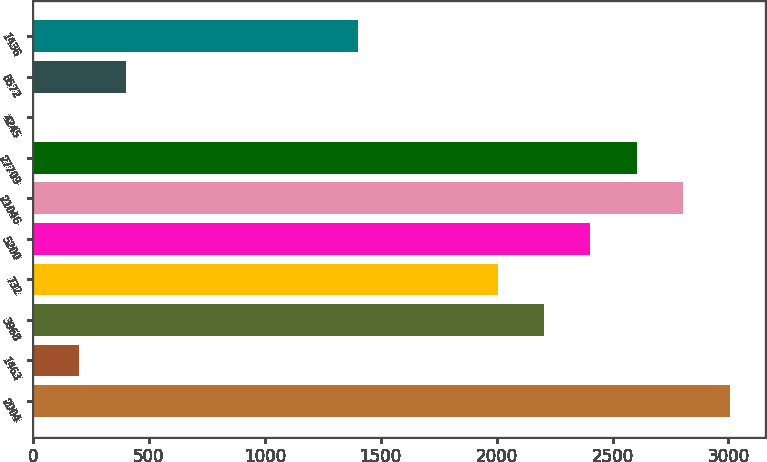<chart> <loc_0><loc_0><loc_500><loc_500><bar_chart><fcel>2004<fcel>1463<fcel>3968<fcel>732<fcel>5200<fcel>21046<fcel>27709<fcel>4245<fcel>8572<fcel>1436<nl><fcel>3005.68<fcel>200.92<fcel>2204.32<fcel>2003.98<fcel>2404.66<fcel>2805.34<fcel>2605<fcel>0.58<fcel>401.26<fcel>1402.96<nl></chart> 